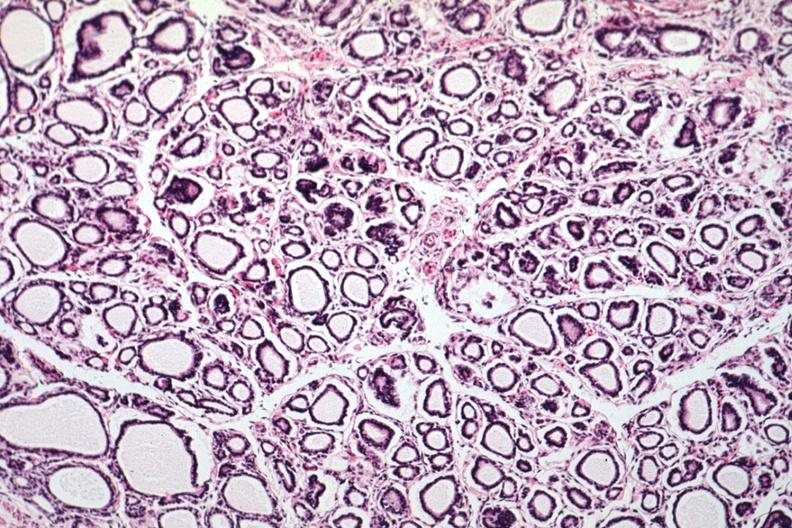s aorta present?
Answer the question using a single word or phrase. No 